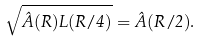Convert formula to latex. <formula><loc_0><loc_0><loc_500><loc_500>\sqrt { \hat { A } ( R ) L ( R / 4 ) } = \hat { A } ( R / 2 ) .</formula> 